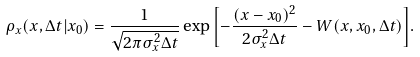Convert formula to latex. <formula><loc_0><loc_0><loc_500><loc_500>\rho _ { x } ( x , \Delta t | x _ { 0 } ) = \frac { 1 } { \sqrt { 2 \pi \sigma _ { x } ^ { 2 } \Delta t } } \exp { \left [ - \frac { ( x - x _ { 0 } ) ^ { 2 } } { 2 \sigma _ { x } ^ { 2 } \Delta t } - W ( x , x _ { 0 } , \Delta t ) \right ] } .</formula> 